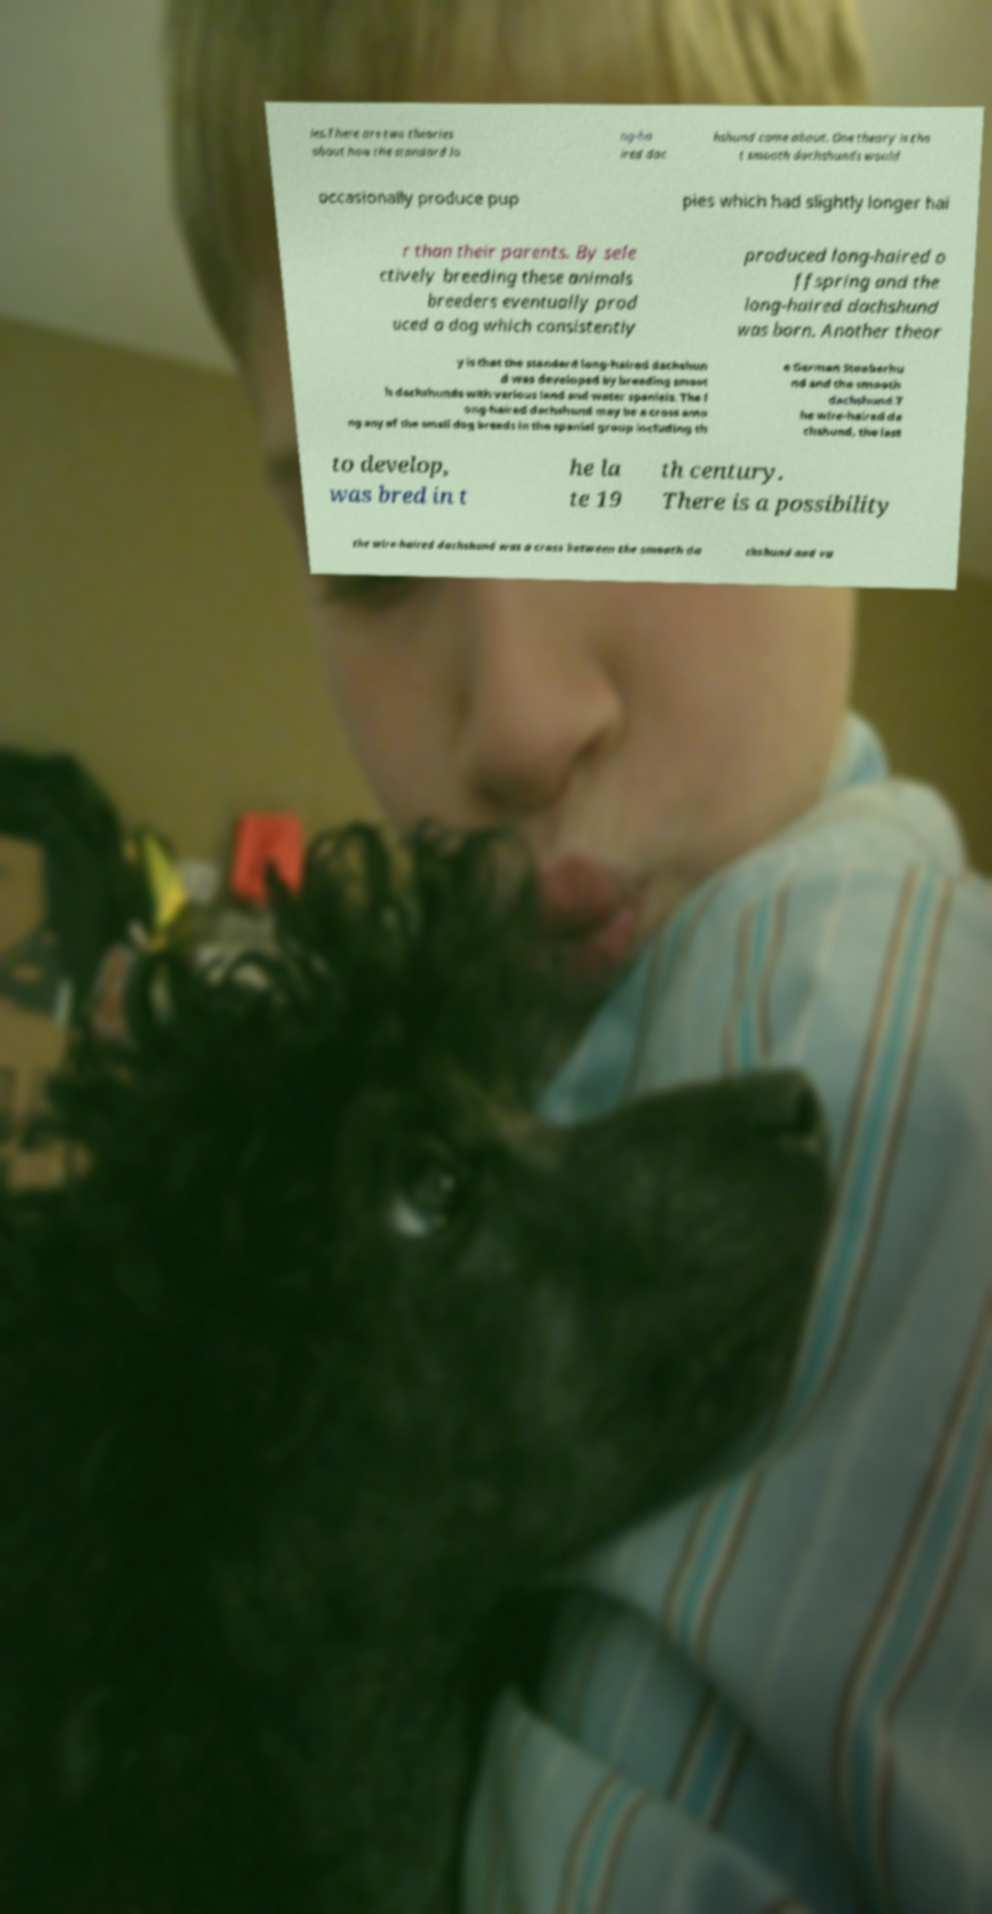What messages or text are displayed in this image? I need them in a readable, typed format. ies.There are two theories about how the standard lo ng-ha ired dac hshund came about. One theory is tha t smooth dachshunds would occasionally produce pup pies which had slightly longer hai r than their parents. By sele ctively breeding these animals breeders eventually prod uced a dog which consistently produced long-haired o ffspring and the long-haired dachshund was born. Another theor y is that the standard long-haired dachshun d was developed by breeding smoot h dachshunds with various land and water spaniels. The l ong-haired dachshund may be a cross amo ng any of the small dog breeds in the spaniel group including th e German Stoeberhu nd and the smooth dachshund.T he wire-haired da chshund, the last to develop, was bred in t he la te 19 th century. There is a possibility the wire-haired dachshund was a cross between the smooth da chshund and va 